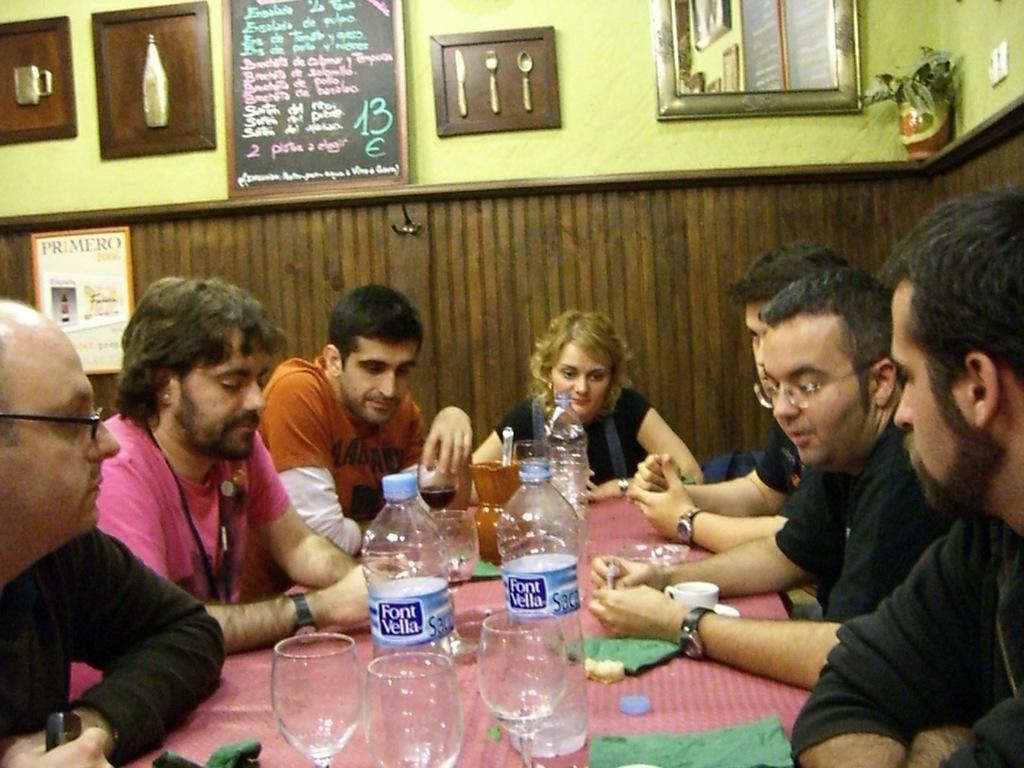Can you describe this image briefly? In this picture we can see a few glasses, bottles, cup, saucer, green objects and other objects visible on the table. We can see a group of people sitting on the chair. There is a person wearing a spectacle and holding an object in his hand. We can see a few boards on the wall. There is a house plant and a white object on the right side. 